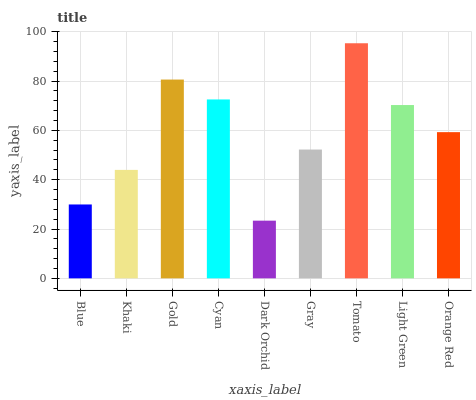Is Dark Orchid the minimum?
Answer yes or no. Yes. Is Tomato the maximum?
Answer yes or no. Yes. Is Khaki the minimum?
Answer yes or no. No. Is Khaki the maximum?
Answer yes or no. No. Is Khaki greater than Blue?
Answer yes or no. Yes. Is Blue less than Khaki?
Answer yes or no. Yes. Is Blue greater than Khaki?
Answer yes or no. No. Is Khaki less than Blue?
Answer yes or no. No. Is Orange Red the high median?
Answer yes or no. Yes. Is Orange Red the low median?
Answer yes or no. Yes. Is Tomato the high median?
Answer yes or no. No. Is Khaki the low median?
Answer yes or no. No. 